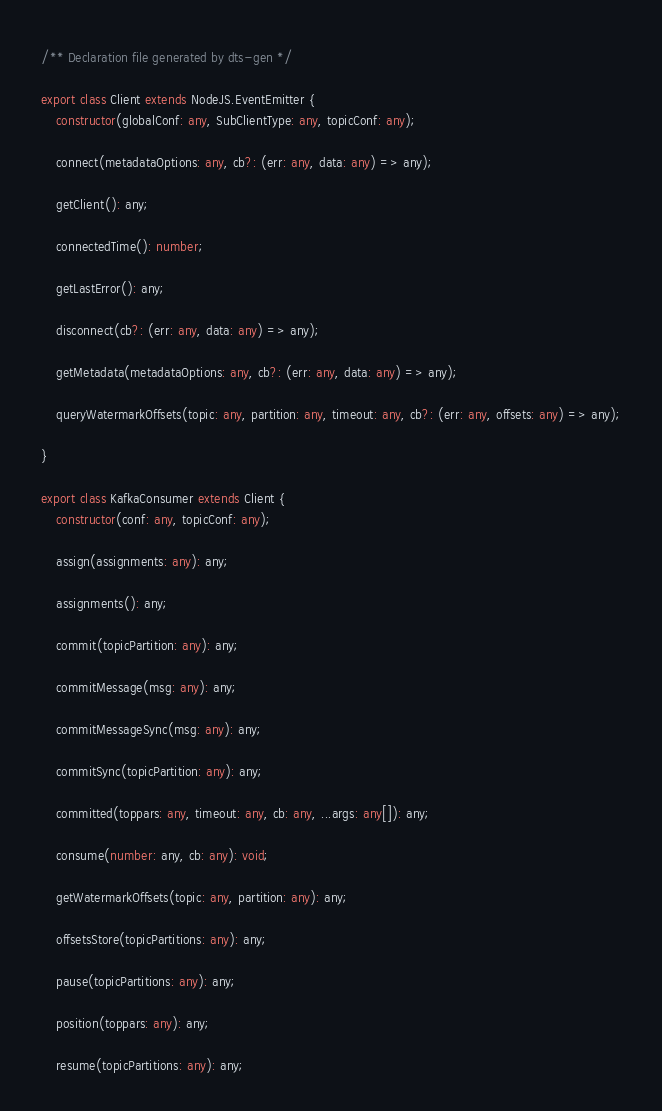<code> <loc_0><loc_0><loc_500><loc_500><_TypeScript_>/** Declaration file generated by dts-gen */

export class Client extends NodeJS.EventEmitter {
    constructor(globalConf: any, SubClientType: any, topicConf: any);

    connect(metadataOptions: any, cb?: (err: any, data: any) => any);

    getClient(): any;

    connectedTime(): number;

    getLastError(): any;

    disconnect(cb?: (err: any, data: any) => any);

    getMetadata(metadataOptions: any, cb?: (err: any, data: any) => any);

    queryWatermarkOffsets(topic: any, partition: any, timeout: any, cb?: (err: any, offsets: any) => any);

}

export class KafkaConsumer extends Client {
    constructor(conf: any, topicConf: any);

    assign(assignments: any): any;

    assignments(): any;

    commit(topicPartition: any): any;

    commitMessage(msg: any): any;

    commitMessageSync(msg: any): any;

    commitSync(topicPartition: any): any;

    committed(toppars: any, timeout: any, cb: any, ...args: any[]): any;

    consume(number: any, cb: any): void;

    getWatermarkOffsets(topic: any, partition: any): any;

    offsetsStore(topicPartitions: any): any;

    pause(topicPartitions: any): any;

    position(toppars: any): any;

    resume(topicPartitions: any): any;
</code> 